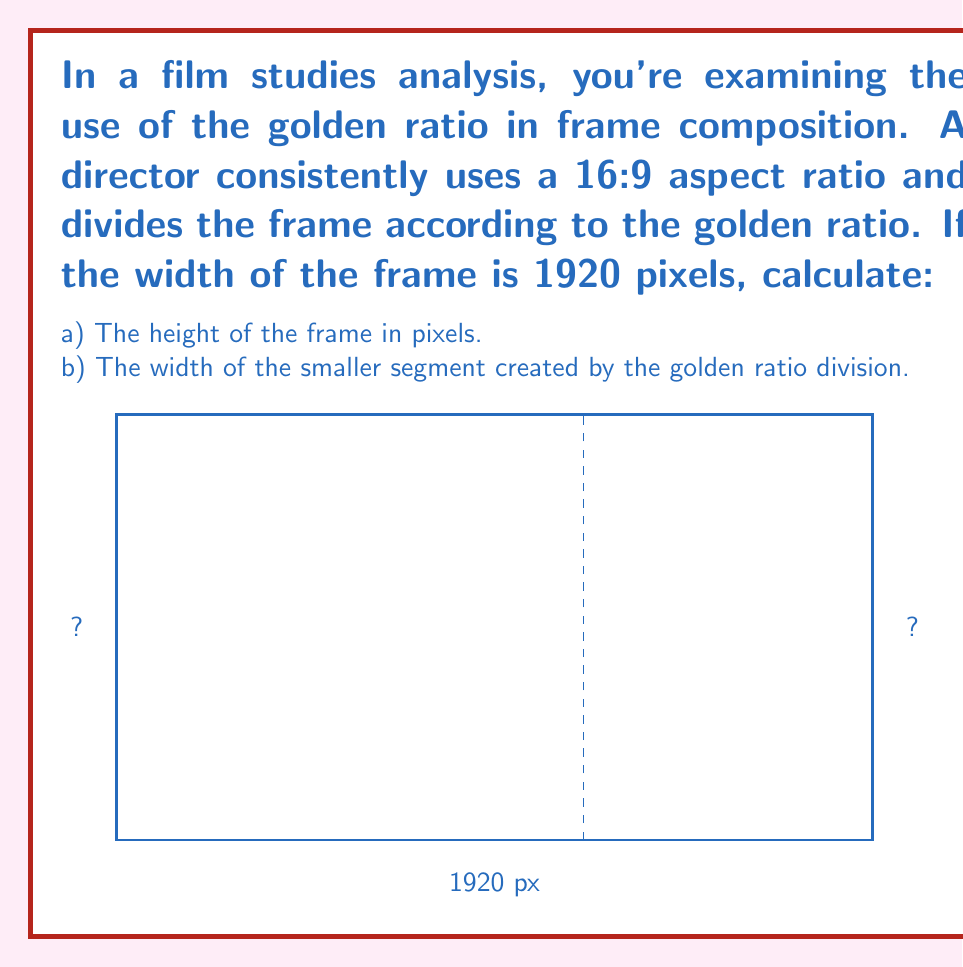Can you answer this question? Let's approach this step-by-step:

1) First, we need to calculate the height of the frame:
   - The aspect ratio is 16:9
   - If width is 1920 pixels, then:
     $\frac{width}{height} = \frac{16}{9}$
     $\frac{1920}{height} = \frac{16}{9}$
   - Cross multiply:
     $9 \times 1920 = 16 \times height$
     $17280 = 16 \times height$
   - Solve for height:
     $height = \frac{17280}{16} = 1080$ pixels

2) Now, let's calculate the golden ratio division:
   - The golden ratio is approximately 1.618033988749895
   - Let's call the smaller segment $x$
   - Then, $\frac{1920}{x} = 1.618033988749895$
   - Solve for $x$:
     $x = \frac{1920}{1.618033988749895} \approx 1186.47$ pixels

3) We can verify:
   $1920 - 1186.47 \approx 733.53$ pixels for the larger segment
   $\frac{1920}{1186.47} \approx 1.618033988749895$ (the golden ratio)
Answer: a) 1080 pixels
b) 1186.47 pixels 